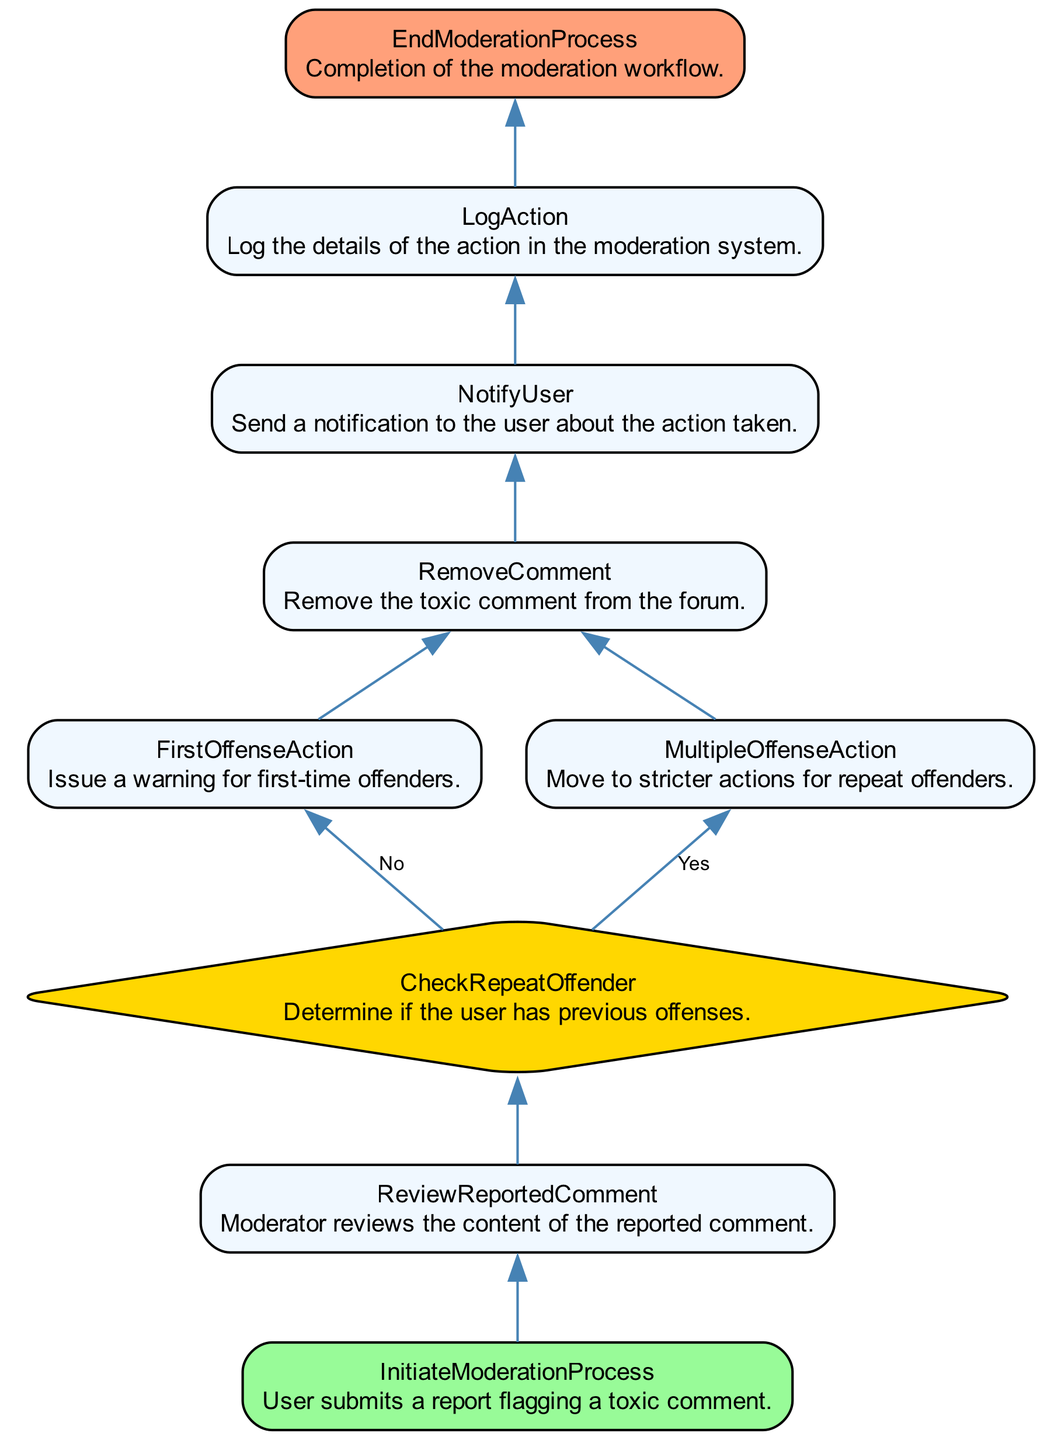What is the starting point of the moderation process? The starting point is labeled "InitiateModerationProcess", which indicates that the process begins when a user submits a report flagging a toxic comment.
Answer: InitiateModerationProcess How many tasks are involved in the moderation workflow? There are five tasks involved: "ReviewReportedComment", "FirstOffenseAction", "MultipleOffenseAction", "RemoveComment", and "NotifyUser".
Answer: Five What action is taken for a first-time offender? The action taken for a first-time offender is to issue a warning, as indicated by the task "FirstOffenseAction".
Answer: Issue a warning What happens after a comment is removed? After the comment is removed, the next step is to send a notification to the user about the action taken, represented by the task "NotifyUser".
Answer: NotifyUser What decision is made at the CheckRepeatOffender node? At the "CheckRepeatOffender" node, the decision is whether the user has previous offenses, leading to different actions for "Yes" or "No".
Answer: Determine previous offenses What is the end point of the moderation workflow? The endpoint of the moderation workflow is labeled "EndModerationProcess", indicating the completion of all tasks associated with moderating toxic comments.
Answer: EndModerationProcess How many edges connect the nodes in the diagram? The diagram contains eight edges indicating the flow of the moderation process between the different nodes.
Answer: Eight What is the first action taken after a comment is reviewed? The first action taken after reviewing a reported comment is to check if the user is a repeat offender, as indicated by the transition to the "CheckRepeatOffender" node.
Answer: CheckRepeatOffender In the event of multiple offenses, what action is taken? For multiple offenses, the action taken is to move to stricter actions as indicated by the task "MultipleOffenseAction".
Answer: Move to stricter actions 